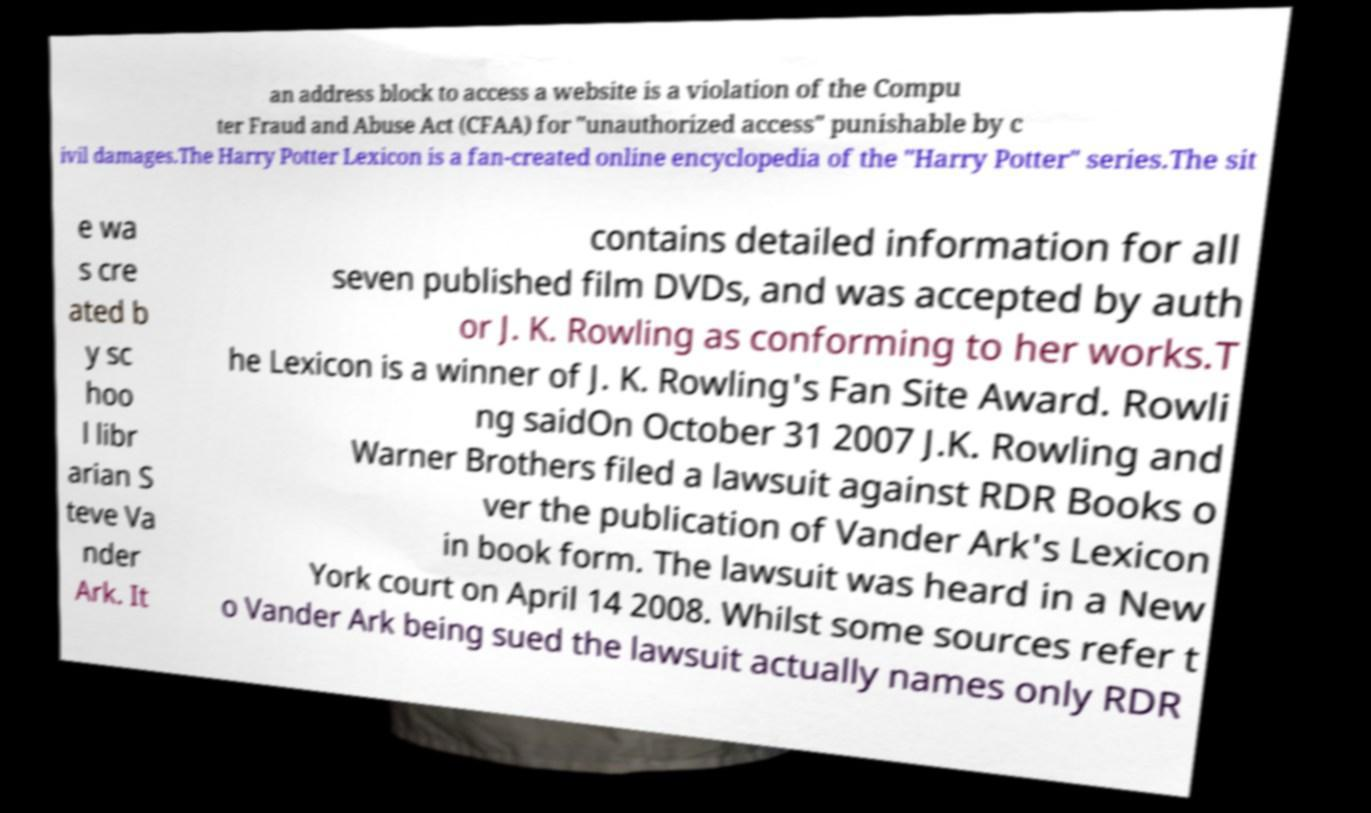Please identify and transcribe the text found in this image. an address block to access a website is a violation of the Compu ter Fraud and Abuse Act (CFAA) for "unauthorized access" punishable by c ivil damages.The Harry Potter Lexicon is a fan-created online encyclopedia of the "Harry Potter" series.The sit e wa s cre ated b y sc hoo l libr arian S teve Va nder Ark. It contains detailed information for all seven published film DVDs, and was accepted by auth or J. K. Rowling as conforming to her works.T he Lexicon is a winner of J. K. Rowling's Fan Site Award. Rowli ng saidOn October 31 2007 J.K. Rowling and Warner Brothers filed a lawsuit against RDR Books o ver the publication of Vander Ark's Lexicon in book form. The lawsuit was heard in a New York court on April 14 2008. Whilst some sources refer t o Vander Ark being sued the lawsuit actually names only RDR 